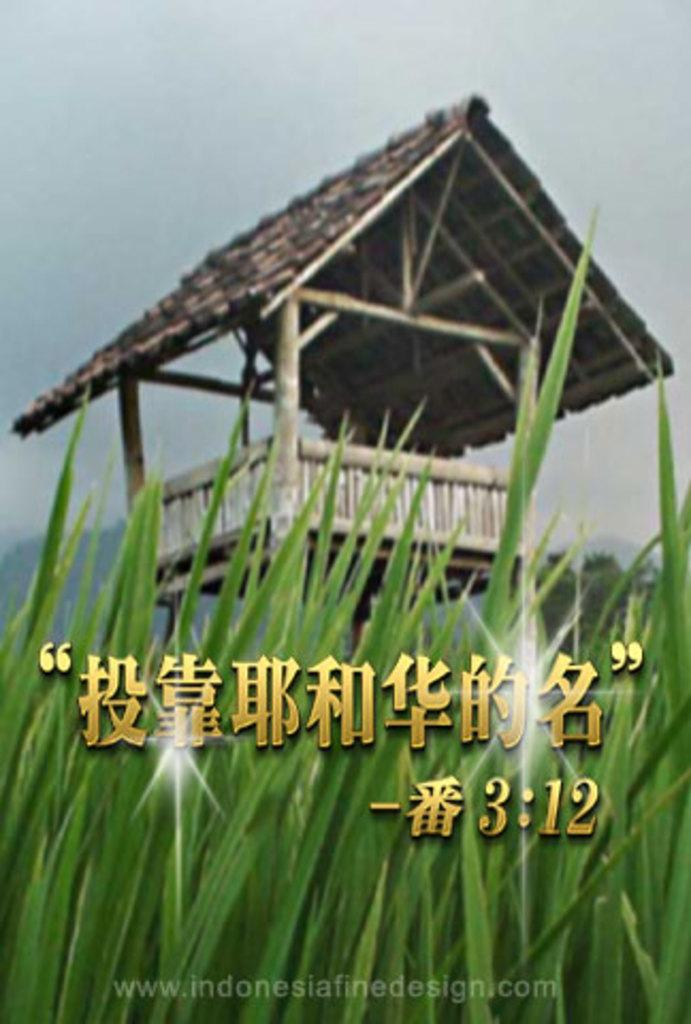What type of vegetation is present in the image? There is grass in the image. What is the color of the grass? The grass is green. What structure can be seen in the background of the image? There is a hut in the background of the image. What part of the natural environment is visible in the image? The sky is visible in the image. What is the color of the sky in the image? The sky is white in the image. Where is the feather located in the image? There is no feather present in the image. What type of meeting is taking place in the image? There is no meeting depicted in the image. 